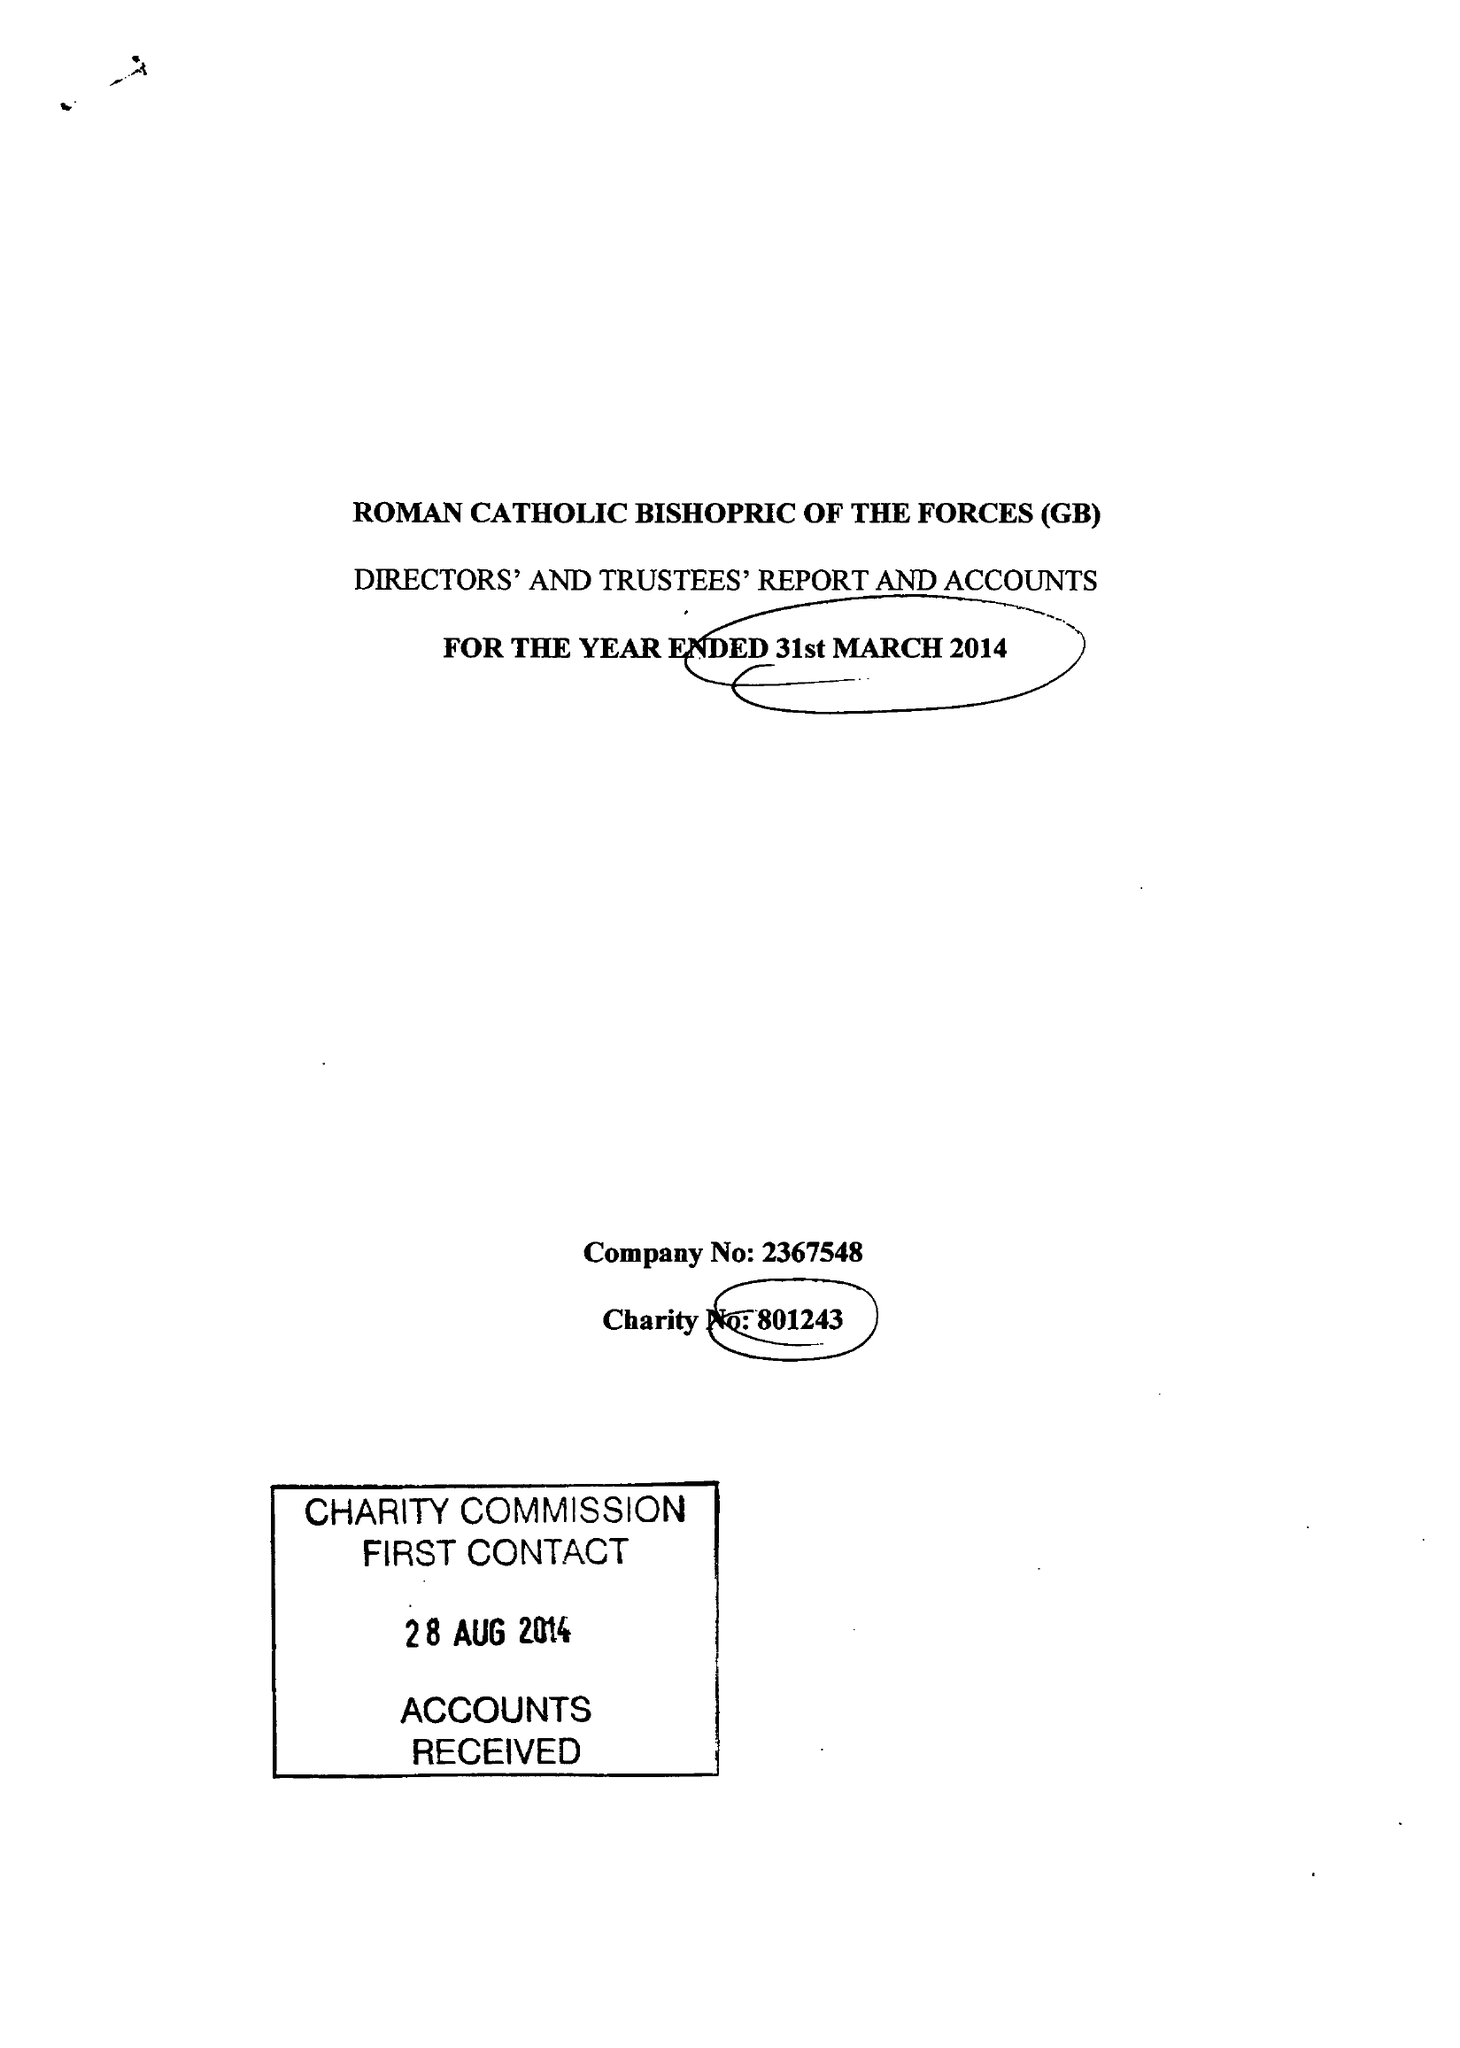What is the value for the report_date?
Answer the question using a single word or phrase. 2014-03-31 